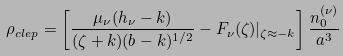Convert formula to latex. <formula><loc_0><loc_0><loc_500><loc_500>\rho _ { c l e p } = \left [ \frac { \mu _ { \nu } ( h _ { \nu } - k ) } { ( \zeta + k ) ( b - k ) ^ { 1 / 2 } } - F _ { \nu } ( \zeta ) | _ { \zeta \approx - k } \right ] \frac { n ^ { ( \nu ) } _ { 0 } } { a ^ { 3 } }</formula> 